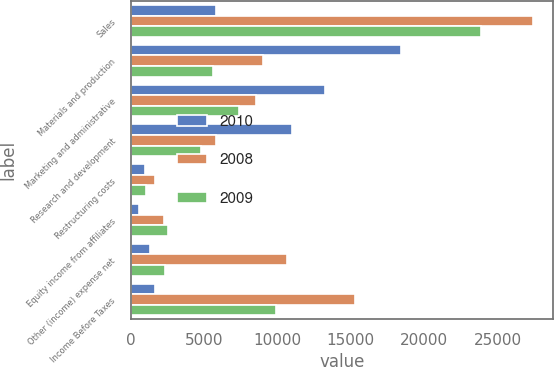Convert chart. <chart><loc_0><loc_0><loc_500><loc_500><stacked_bar_chart><ecel><fcel>Sales<fcel>Materials and production<fcel>Marketing and administrative<fcel>Research and development<fcel>Restructuring costs<fcel>Equity income from affiliates<fcel>Other (income) expense net<fcel>Income Before Taxes<nl><fcel>2010<fcel>5845<fcel>18396<fcel>13245<fcel>10991<fcel>985<fcel>587<fcel>1304<fcel>1653<nl><fcel>2008<fcel>27428<fcel>9019<fcel>8543<fcel>5845<fcel>1634<fcel>2235<fcel>10668<fcel>15290<nl><fcel>2009<fcel>23850<fcel>5583<fcel>7377<fcel>4805<fcel>1033<fcel>2561<fcel>2318<fcel>9931<nl></chart> 